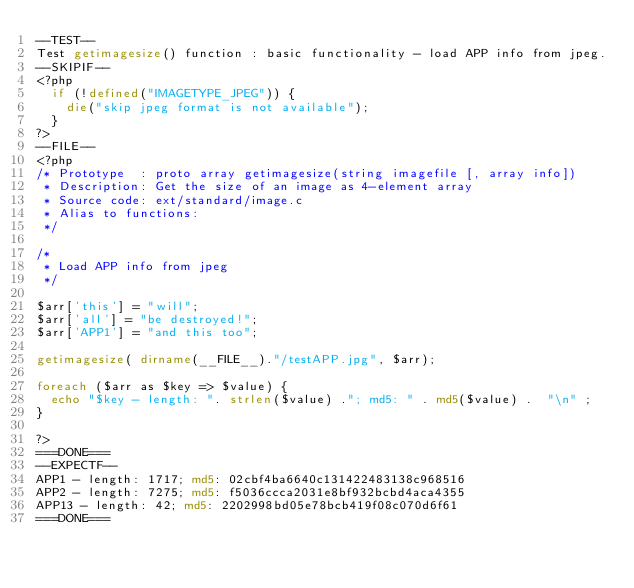Convert code to text. <code><loc_0><loc_0><loc_500><loc_500><_PHP_>--TEST--
Test getimagesize() function : basic functionality - load APP info from jpeg.
--SKIPIF--
<?php
	if (!defined("IMAGETYPE_JPEG")) {
		die("skip jpeg format is not available");
	}
?>
--FILE--
<?php
/* Prototype  : proto array getimagesize(string imagefile [, array info])
 * Description: Get the size of an image as 4-element array
 * Source code: ext/standard/image.c
 * Alias to functions:
 */

/*
 * Load APP info from jpeg
 */

$arr['this'] = "will";
$arr['all'] = "be destroyed!";
$arr['APP1'] = "and this too";

getimagesize( dirname(__FILE__)."/testAPP.jpg", $arr);

foreach ($arr as $key => $value) {
	echo "$key - length: ". strlen($value) ."; md5: " . md5($value) .  "\n" ;
}

?>
===DONE===
--EXPECTF--
APP1 - length: 1717; md5: 02cbf4ba6640c131422483138c968516
APP2 - length: 7275; md5: f5036ccca2031e8bf932bcbd4aca4355
APP13 - length: 42; md5: 2202998bd05e78bcb419f08c070d6f61
===DONE===
</code> 